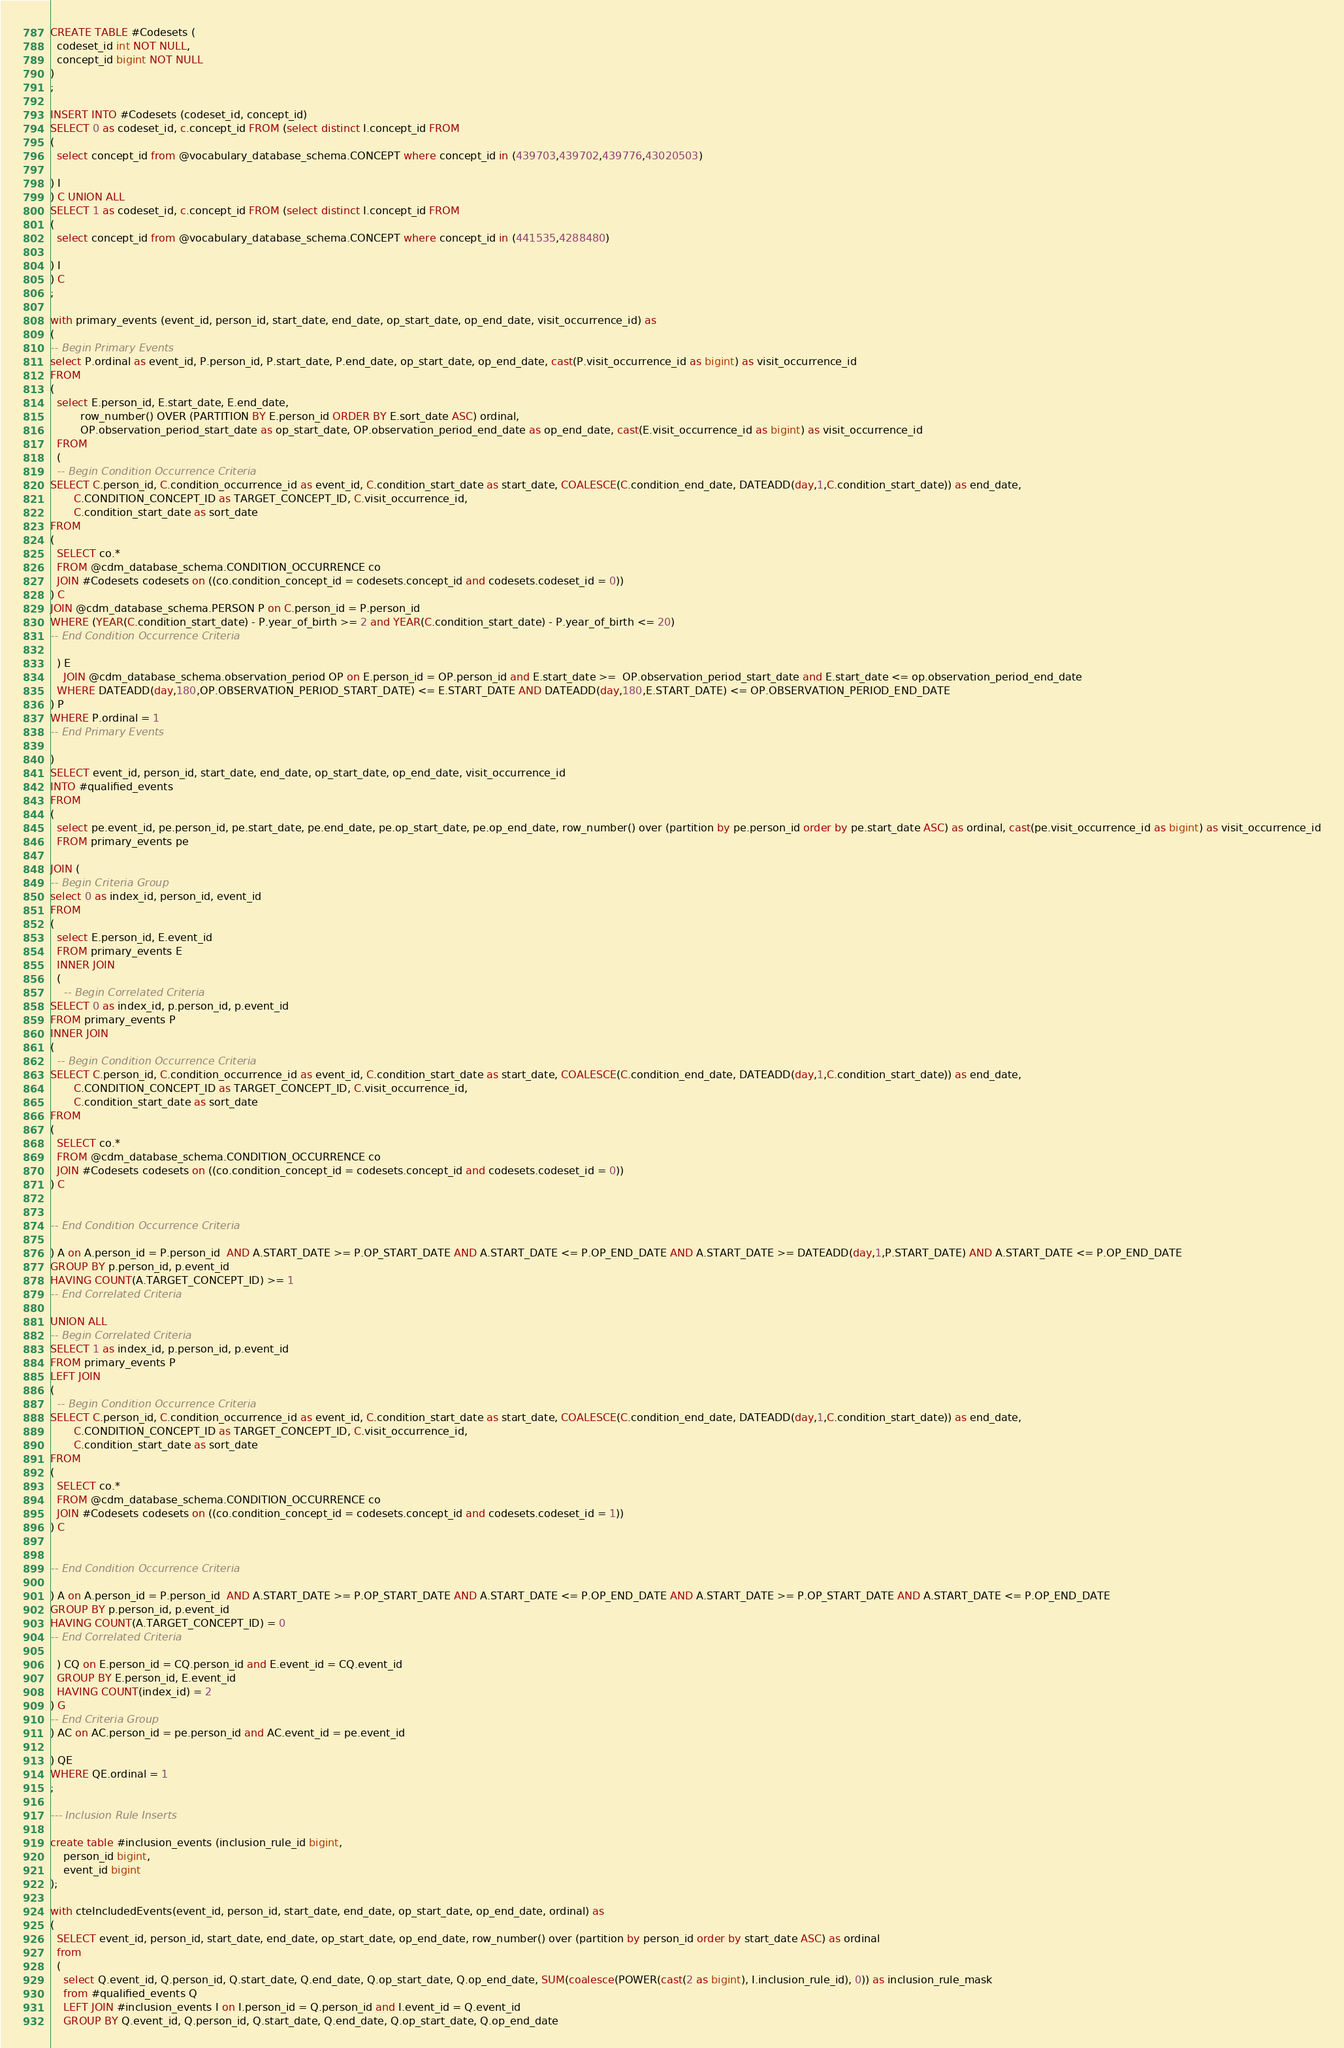<code> <loc_0><loc_0><loc_500><loc_500><_SQL_>CREATE TABLE #Codesets (
  codeset_id int NOT NULL,
  concept_id bigint NOT NULL
)
;

INSERT INTO #Codesets (codeset_id, concept_id)
SELECT 0 as codeset_id, c.concept_id FROM (select distinct I.concept_id FROM
( 
  select concept_id from @vocabulary_database_schema.CONCEPT where concept_id in (439703,439702,439776,43020503)

) I
) C UNION ALL 
SELECT 1 as codeset_id, c.concept_id FROM (select distinct I.concept_id FROM
( 
  select concept_id from @vocabulary_database_schema.CONCEPT where concept_id in (441535,4288480)

) I
) C
;

with primary_events (event_id, person_id, start_date, end_date, op_start_date, op_end_date, visit_occurrence_id) as
(
-- Begin Primary Events
select P.ordinal as event_id, P.person_id, P.start_date, P.end_date, op_start_date, op_end_date, cast(P.visit_occurrence_id as bigint) as visit_occurrence_id
FROM
(
  select E.person_id, E.start_date, E.end_date,
         row_number() OVER (PARTITION BY E.person_id ORDER BY E.sort_date ASC) ordinal,
         OP.observation_period_start_date as op_start_date, OP.observation_period_end_date as op_end_date, cast(E.visit_occurrence_id as bigint) as visit_occurrence_id
  FROM 
  (
  -- Begin Condition Occurrence Criteria
SELECT C.person_id, C.condition_occurrence_id as event_id, C.condition_start_date as start_date, COALESCE(C.condition_end_date, DATEADD(day,1,C.condition_start_date)) as end_date,
       C.CONDITION_CONCEPT_ID as TARGET_CONCEPT_ID, C.visit_occurrence_id,
       C.condition_start_date as sort_date
FROM 
(
  SELECT co.* 
  FROM @cdm_database_schema.CONDITION_OCCURRENCE co
  JOIN #Codesets codesets on ((co.condition_concept_id = codesets.concept_id and codesets.codeset_id = 0))
) C
JOIN @cdm_database_schema.PERSON P on C.person_id = P.person_id
WHERE (YEAR(C.condition_start_date) - P.year_of_birth >= 2 and YEAR(C.condition_start_date) - P.year_of_birth <= 20)
-- End Condition Occurrence Criteria

  ) E
	JOIN @cdm_database_schema.observation_period OP on E.person_id = OP.person_id and E.start_date >=  OP.observation_period_start_date and E.start_date <= op.observation_period_end_date
  WHERE DATEADD(day,180,OP.OBSERVATION_PERIOD_START_DATE) <= E.START_DATE AND DATEADD(day,180,E.START_DATE) <= OP.OBSERVATION_PERIOD_END_DATE
) P
WHERE P.ordinal = 1
-- End Primary Events

)
SELECT event_id, person_id, start_date, end_date, op_start_date, op_end_date, visit_occurrence_id
INTO #qualified_events
FROM 
(
  select pe.event_id, pe.person_id, pe.start_date, pe.end_date, pe.op_start_date, pe.op_end_date, row_number() over (partition by pe.person_id order by pe.start_date ASC) as ordinal, cast(pe.visit_occurrence_id as bigint) as visit_occurrence_id
  FROM primary_events pe
  
JOIN (
-- Begin Criteria Group
select 0 as index_id, person_id, event_id
FROM
(
  select E.person_id, E.event_id 
  FROM primary_events E
  INNER JOIN
  (
    -- Begin Correlated Criteria
SELECT 0 as index_id, p.person_id, p.event_id
FROM primary_events P
INNER JOIN
(
  -- Begin Condition Occurrence Criteria
SELECT C.person_id, C.condition_occurrence_id as event_id, C.condition_start_date as start_date, COALESCE(C.condition_end_date, DATEADD(day,1,C.condition_start_date)) as end_date,
       C.CONDITION_CONCEPT_ID as TARGET_CONCEPT_ID, C.visit_occurrence_id,
       C.condition_start_date as sort_date
FROM 
(
  SELECT co.* 
  FROM @cdm_database_schema.CONDITION_OCCURRENCE co
  JOIN #Codesets codesets on ((co.condition_concept_id = codesets.concept_id and codesets.codeset_id = 0))
) C


-- End Condition Occurrence Criteria

) A on A.person_id = P.person_id  AND A.START_DATE >= P.OP_START_DATE AND A.START_DATE <= P.OP_END_DATE AND A.START_DATE >= DATEADD(day,1,P.START_DATE) AND A.START_DATE <= P.OP_END_DATE
GROUP BY p.person_id, p.event_id
HAVING COUNT(A.TARGET_CONCEPT_ID) >= 1
-- End Correlated Criteria

UNION ALL
-- Begin Correlated Criteria
SELECT 1 as index_id, p.person_id, p.event_id
FROM primary_events P
LEFT JOIN
(
  -- Begin Condition Occurrence Criteria
SELECT C.person_id, C.condition_occurrence_id as event_id, C.condition_start_date as start_date, COALESCE(C.condition_end_date, DATEADD(day,1,C.condition_start_date)) as end_date,
       C.CONDITION_CONCEPT_ID as TARGET_CONCEPT_ID, C.visit_occurrence_id,
       C.condition_start_date as sort_date
FROM 
(
  SELECT co.* 
  FROM @cdm_database_schema.CONDITION_OCCURRENCE co
  JOIN #Codesets codesets on ((co.condition_concept_id = codesets.concept_id and codesets.codeset_id = 1))
) C


-- End Condition Occurrence Criteria

) A on A.person_id = P.person_id  AND A.START_DATE >= P.OP_START_DATE AND A.START_DATE <= P.OP_END_DATE AND A.START_DATE >= P.OP_START_DATE AND A.START_DATE <= P.OP_END_DATE
GROUP BY p.person_id, p.event_id
HAVING COUNT(A.TARGET_CONCEPT_ID) = 0
-- End Correlated Criteria

  ) CQ on E.person_id = CQ.person_id and E.event_id = CQ.event_id
  GROUP BY E.person_id, E.event_id
  HAVING COUNT(index_id) = 2
) G
-- End Criteria Group
) AC on AC.person_id = pe.person_id and AC.event_id = pe.event_id

) QE
WHERE QE.ordinal = 1
;

--- Inclusion Rule Inserts

create table #inclusion_events (inclusion_rule_id bigint,
	person_id bigint,
	event_id bigint
);

with cteIncludedEvents(event_id, person_id, start_date, end_date, op_start_date, op_end_date, ordinal) as
(
  SELECT event_id, person_id, start_date, end_date, op_start_date, op_end_date, row_number() over (partition by person_id order by start_date ASC) as ordinal
  from
  (
    select Q.event_id, Q.person_id, Q.start_date, Q.end_date, Q.op_start_date, Q.op_end_date, SUM(coalesce(POWER(cast(2 as bigint), I.inclusion_rule_id), 0)) as inclusion_rule_mask
    from #qualified_events Q
    LEFT JOIN #inclusion_events I on I.person_id = Q.person_id and I.event_id = Q.event_id
    GROUP BY Q.event_id, Q.person_id, Q.start_date, Q.end_date, Q.op_start_date, Q.op_end_date</code> 